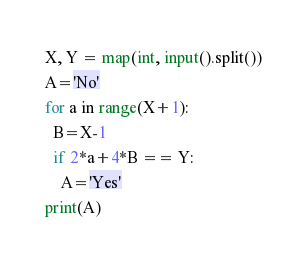<code> <loc_0><loc_0><loc_500><loc_500><_Python_>X, Y = map(int, input().split())
A='No'
for a in range(X+1):
  B=X-1
  if 2*a+4*B == Y:
   	A='Yes'
print(A)
</code> 